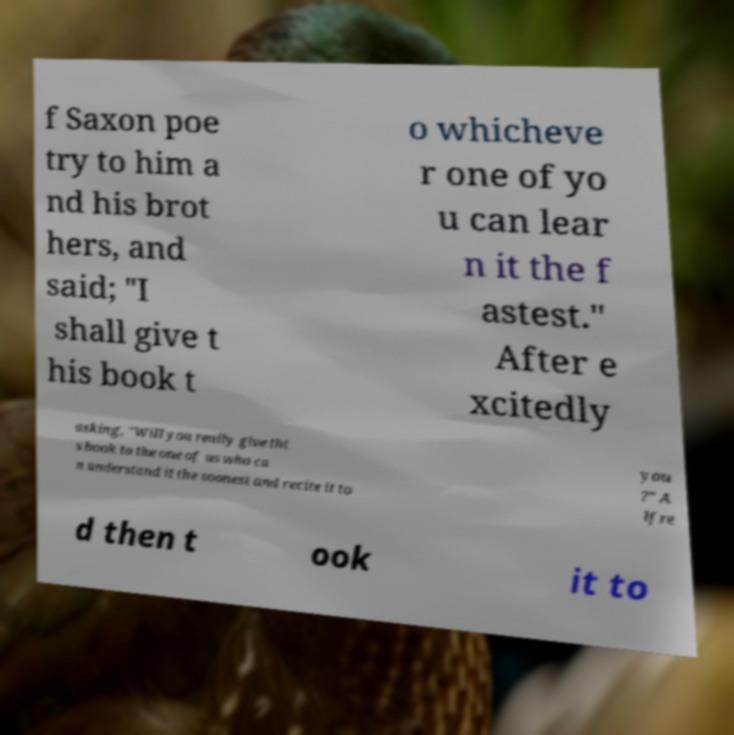Can you read and provide the text displayed in the image?This photo seems to have some interesting text. Can you extract and type it out for me? f Saxon poe try to him a nd his brot hers, and said; "I shall give t his book t o whicheve r one of yo u can lear n it the f astest." After e xcitedly asking, "Will you really give thi s book to the one of us who ca n understand it the soonest and recite it to you ?" A lfre d then t ook it to 